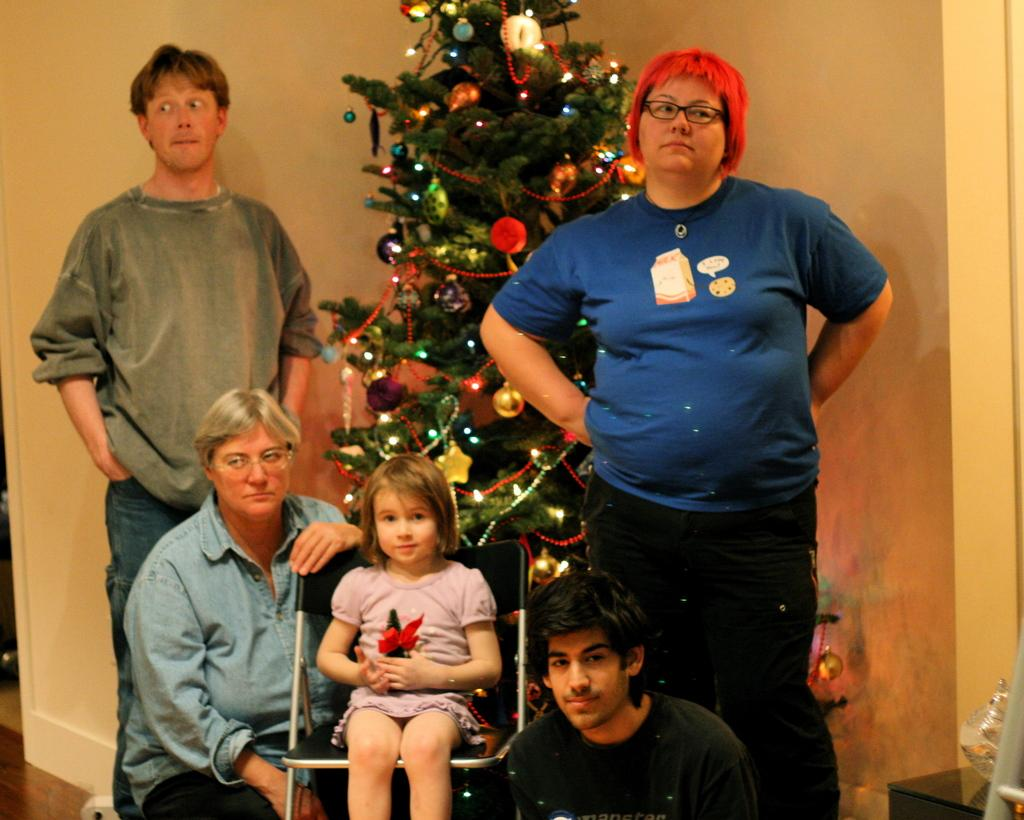How many people are in the image? There is a group of people in the image. What is the girl in the image doing? The girl is sitting on a chair. What is the girl holding in the image? The girl is holding an object. What can be seen in the background of the image? There is a wall, a Christmas tree, and other objects visible in the background of the image. Where are the bears located in the image? There are no bears present in the image. What is the position of the Christmas tree in relation to the girl? The position of the Christmas tree in relation to the girl cannot be determined from the image, as it is in the background. 